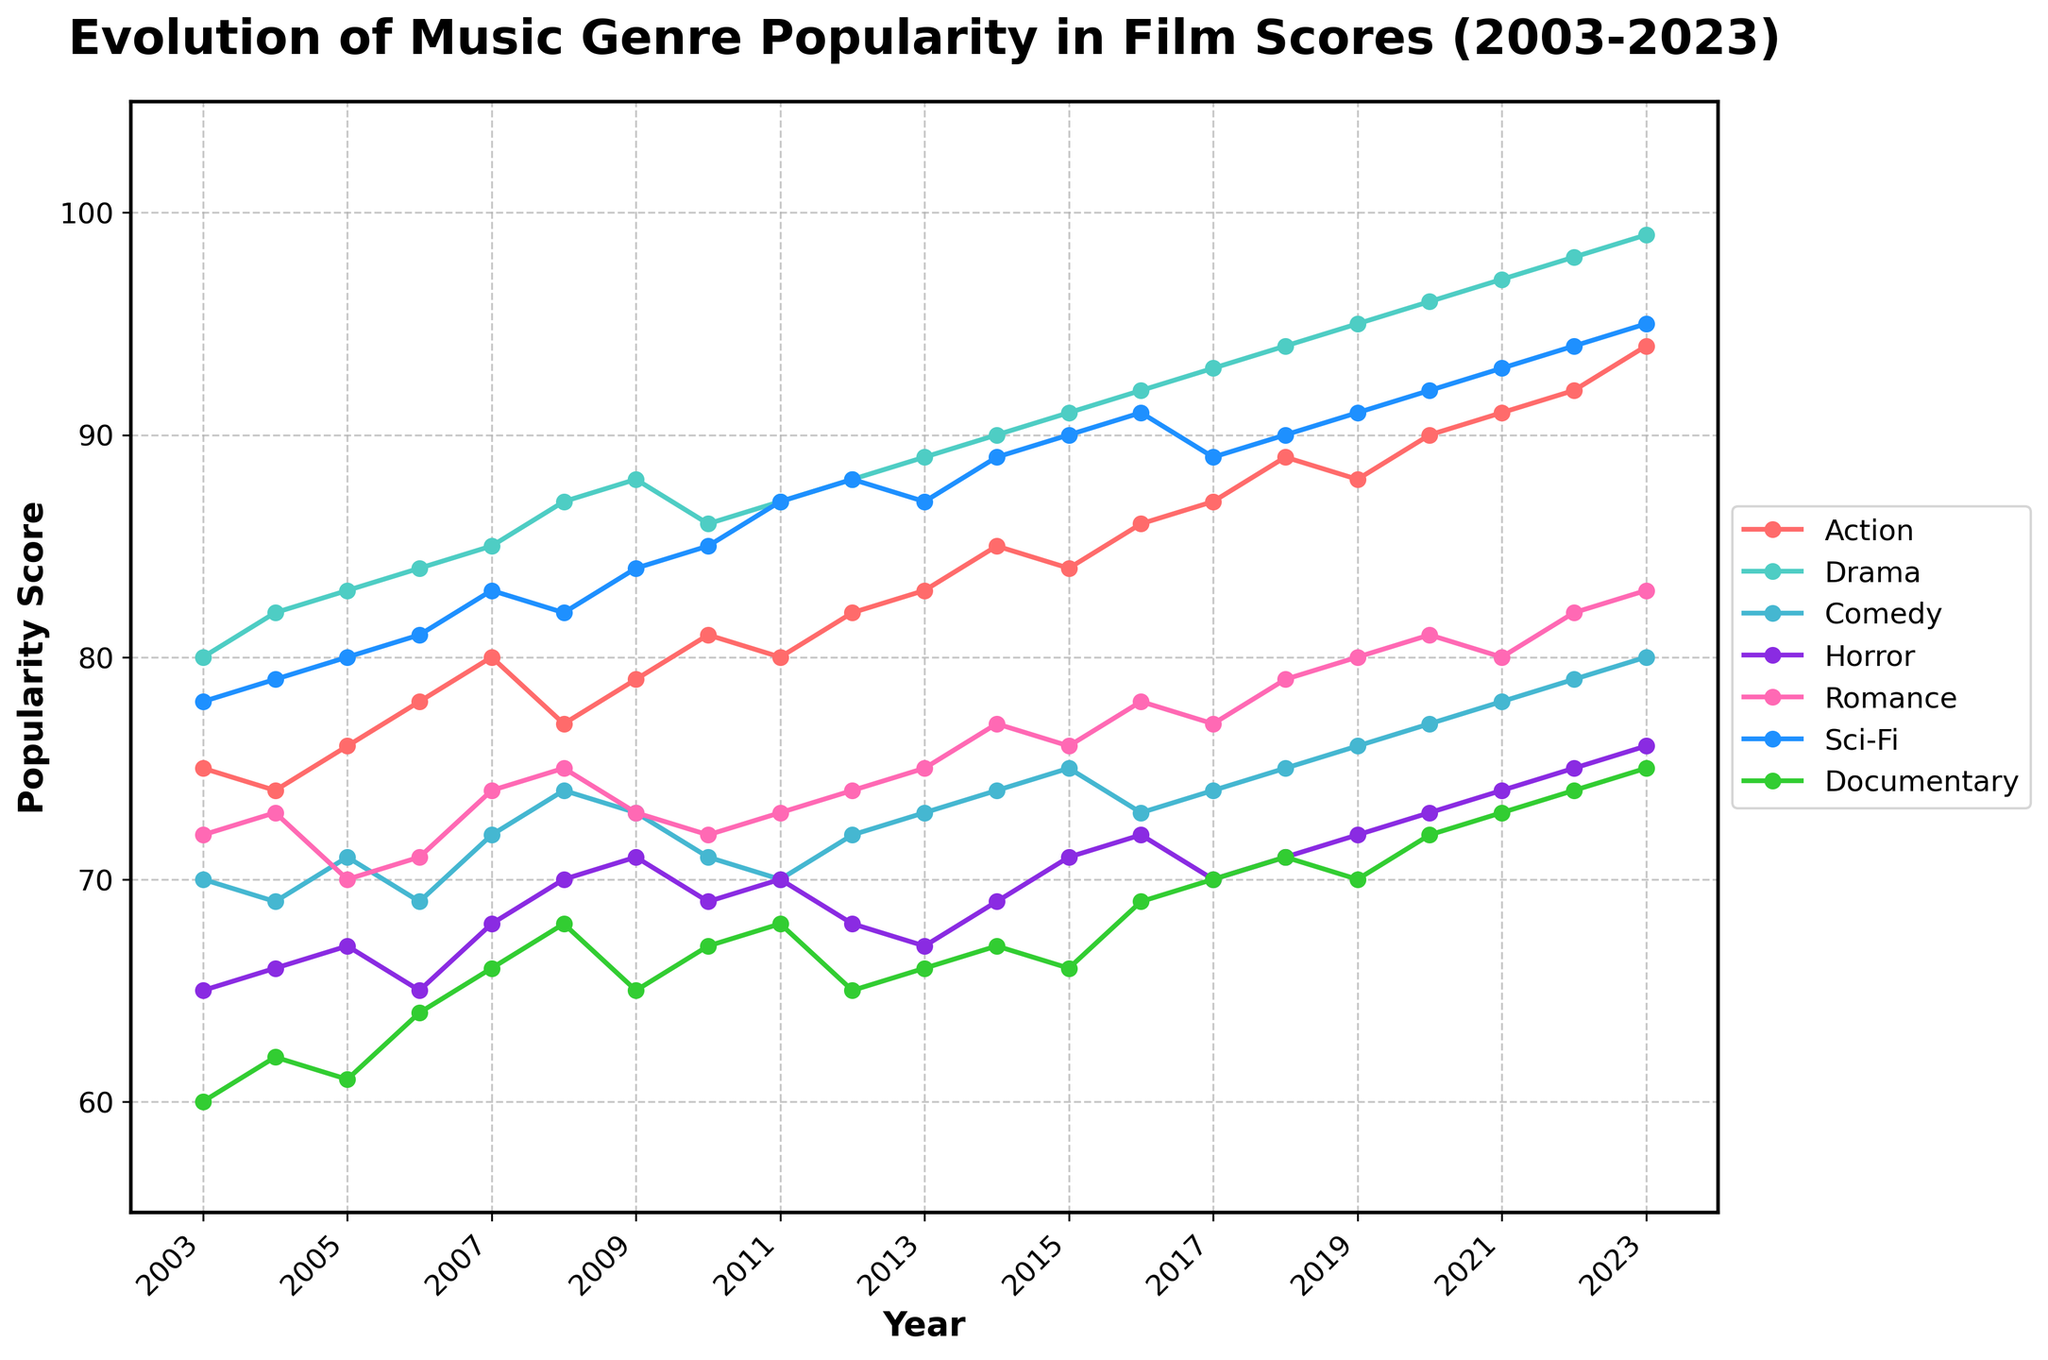what is the title of the figure? The title of the figure is displayed at the top, providing a clear and large-sized text summarizing the content of the plot.
Answer: Evolution of Music Genre Popularity in Film Scores (2003-2023) What is the popularity score for the Documentary genre in 2010? Locate the line representing the Documentary genre (green) on the plot and find the value corresponding to the year 2010
Answer: 67 Which music genre showed the most significant increase in popularity from 2003 to 2023? Track the trends of each line from 2003 to 2023 and identify which line shows the steepest overall rise.
Answer: Drama Between which two years did the Sci-Fi genre show the most significant drop in popularity? Look at the Sci-Fi (blue) line and identify the two years where the slope is steepest in a downward direction.
Answer: 2012-2013 What was the popularity score for Romance in 2020, and how does it compare to its score in 2013? Locate the points for Romance on the line graph for the years 2020 and 2013. Note the values and calculate the difference.
Answer: 2020: 81, 2013: 75; Difference: 81 - 75 = 6 How has the popularity of the Comedy genre changed from 2003 to 2023? Follow the line representing the Comedy genre, noting its values at the start and end points.
Answer: Increased from 70 in 2003 to 80 in 2023 What is the average popularity score of the Action genre over the years? Sum up all the popularity scores for the Action genre from 2003 to 2023 and divide by the number of years.
Answer: (75+74+76+78+80+77+79+81+80+82+83+85+84+86+87+89+88+90+91+92+94)/21 = 83 Which genre had the lowest popularity score in 2007? Identify the lowest point across all genre lines in the year 2007.
Answer: Horror How does the popularity trend of Horror compare to Sci-Fi over the 20 years? Observe and compare the general slope of both the Horror and Sci-Fi lines over the period to see which goes up more steadily or has more fluctuations.
Answer: Sci-Fi had a steady increase, while Horror had more fluctuations but also an overall increase Which genre shows the least variation in popularity scores throughout the years? Look at the lines and observe the one that has the least vertical fluctuation from its initial to the final year.
Answer: Documentary 